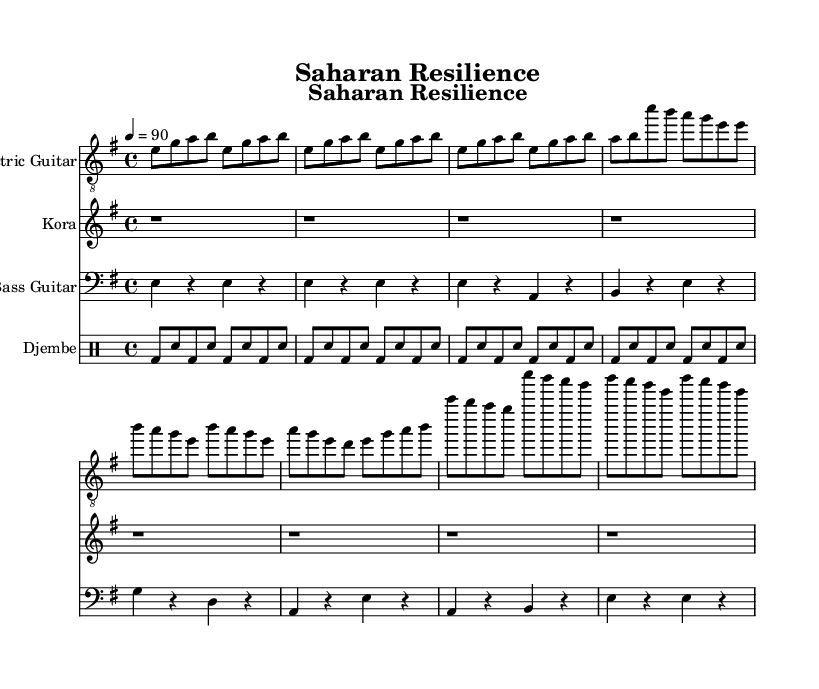What is the key signature of this music? The key signature is E minor, indicated by the absence of sharps or flats in the staff. We confirm this by looking at the first symbol for the key signature, which places a sharp on the F for the E minor scale.
Answer: E minor What is the time signature of this piece? The time signature is 4/4, which means there are four beats per measure, and the quarter note receives one beat. This can be deduced from the notations that show the segments dividing evenly into four beats per bar.
Answer: 4/4 What is the tempo marking of the piece? The tempo marking is 90 beats per minute, indicated by the tempo instruction at the start of the score that tells how fast the piece should be played.
Answer: 90 How many measures are in the verse section? The verse section consists of 2 measures, which can be counted by looking at the notational divisions that separate the musical ideas in the verse.
Answer: 2 measures What instruments are used in this piece? The instruments used are Electric Guitar, Kora, Bass Guitar, and Djembe, as identified by the staff headings for each instrument in the score layout.
Answer: Electric Guitar, Kora, Bass Guitar, Djembe Which theme does the chorus mainly emphasize? The chorus mainly emphasizes the theme of resilience in the face of struggle, which can be inferred by analyzing the musical patterns and repetitions that reinforce this concept through variations in melody.
Answer: Resilience What type of rhythm is used in the djembe part? The rhythm used in the djembe part is a simplified syncopated pattern, indicated by the alternating bass and snare drum sounds that create a driving force in the overall sound.
Answer: Simplified syncopated pattern 